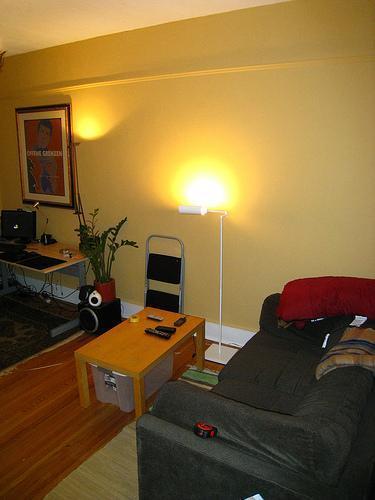How many couches are there?
Give a very brief answer. 1. 